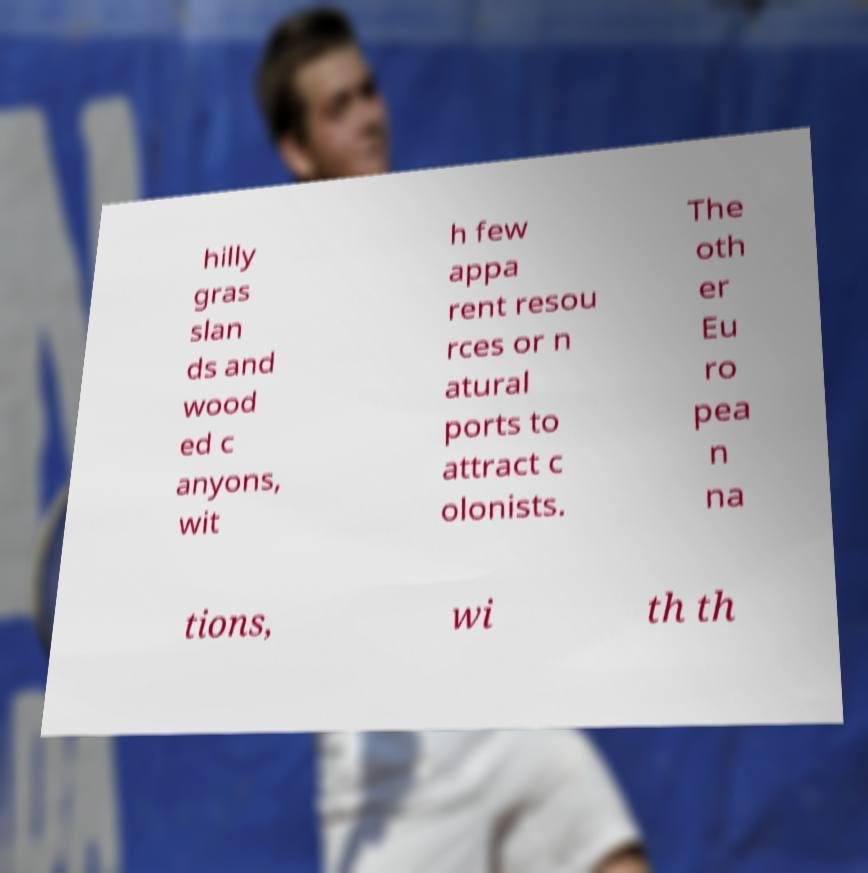Can you accurately transcribe the text from the provided image for me? hilly gras slan ds and wood ed c anyons, wit h few appa rent resou rces or n atural ports to attract c olonists. The oth er Eu ro pea n na tions, wi th th 